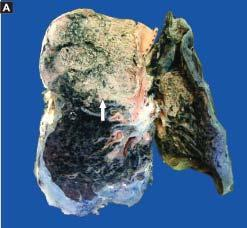s the cellular exudates in the alveolar lumina lying separated from the septal walls by a clear space?
Answer the question using a single word or phrase. Yes 